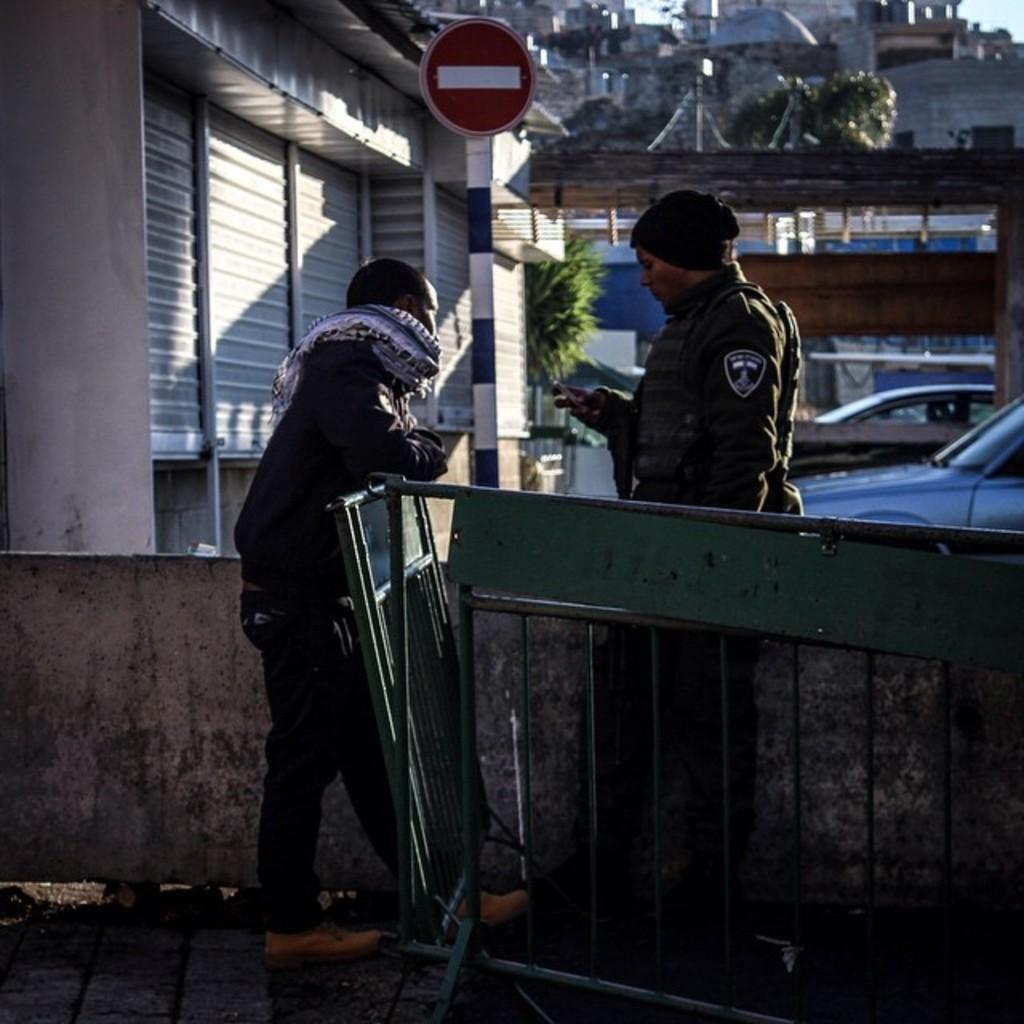In one or two sentences, can you explain what this image depicts? In this image, we can see two people are standing on the surface. Here a person is holding an object. Here we can see barricades, wall. In the background we can see shutters, sign board, pole, plants, vehicles and houses. 